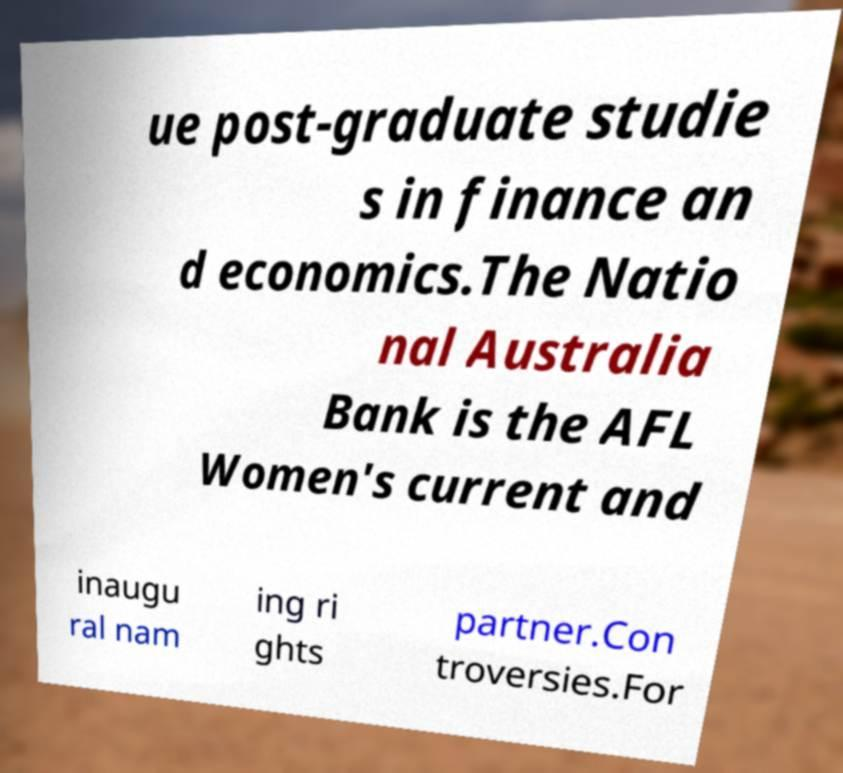Could you extract and type out the text from this image? ue post-graduate studie s in finance an d economics.The Natio nal Australia Bank is the AFL Women's current and inaugu ral nam ing ri ghts partner.Con troversies.For 